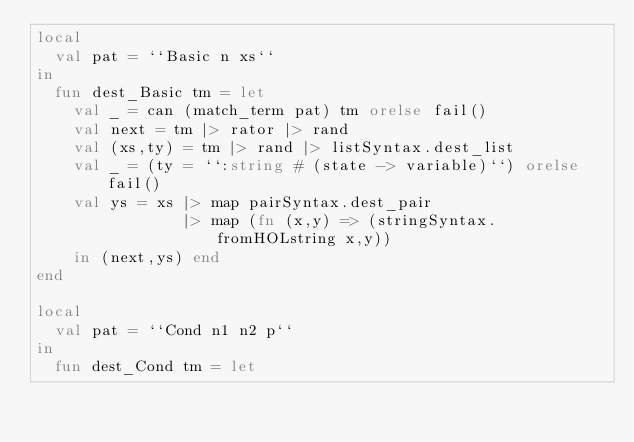Convert code to text. <code><loc_0><loc_0><loc_500><loc_500><_SML_>local
  val pat = ``Basic n xs``
in
  fun dest_Basic tm = let
    val _ = can (match_term pat) tm orelse fail()
    val next = tm |> rator |> rand
    val (xs,ty) = tm |> rand |> listSyntax.dest_list
    val _ = (ty = ``:string # (state -> variable)``) orelse fail()
    val ys = xs |> map pairSyntax.dest_pair
                |> map (fn (x,y) => (stringSyntax.fromHOLstring x,y))
    in (next,ys) end
end

local
  val pat = ``Cond n1 n2 p``
in
  fun dest_Cond tm = let</code> 